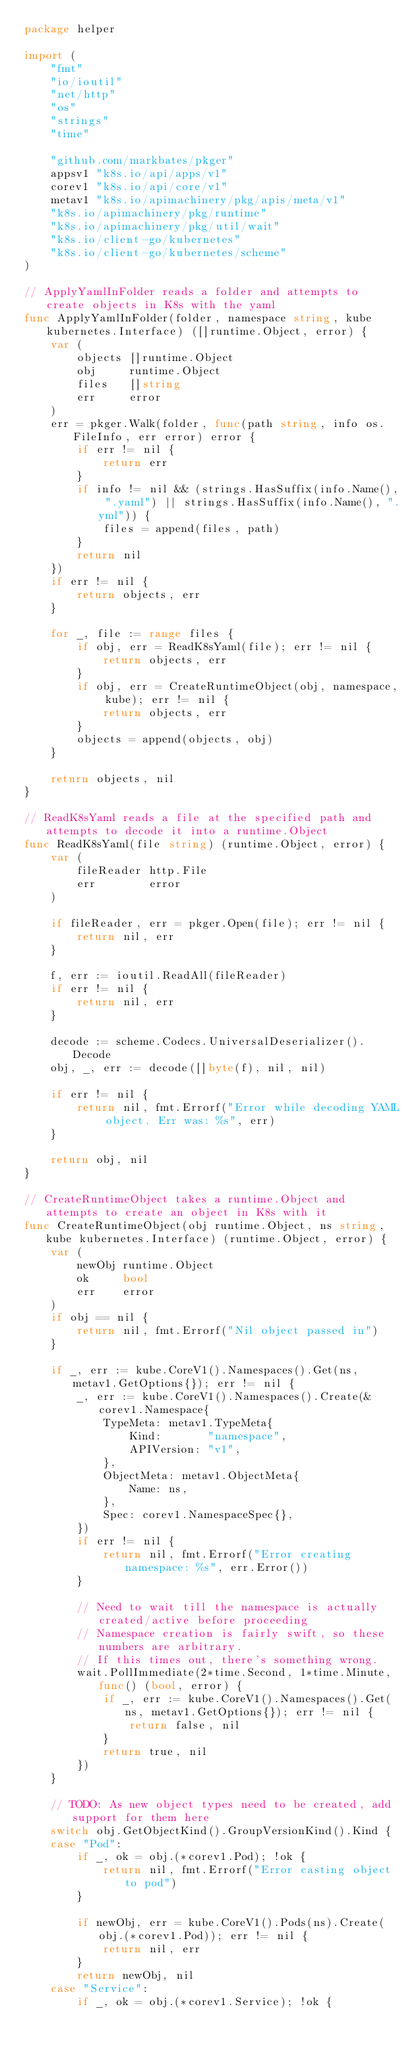<code> <loc_0><loc_0><loc_500><loc_500><_Go_>package helper

import (
	"fmt"
	"io/ioutil"
	"net/http"
	"os"
	"strings"
	"time"

	"github.com/markbates/pkger"
	appsv1 "k8s.io/api/apps/v1"
	corev1 "k8s.io/api/core/v1"
	metav1 "k8s.io/apimachinery/pkg/apis/meta/v1"
	"k8s.io/apimachinery/pkg/runtime"
	"k8s.io/apimachinery/pkg/util/wait"
	"k8s.io/client-go/kubernetes"
	"k8s.io/client-go/kubernetes/scheme"
)

// ApplyYamlInFolder reads a folder and attempts to create objects in K8s with the yaml
func ApplyYamlInFolder(folder, namespace string, kube kubernetes.Interface) ([]runtime.Object, error) {
	var (
		objects []runtime.Object
		obj     runtime.Object
		files   []string
		err     error
	)
	err = pkger.Walk(folder, func(path string, info os.FileInfo, err error) error {
		if err != nil {
			return err
		}
		if info != nil && (strings.HasSuffix(info.Name(), ".yaml") || strings.HasSuffix(info.Name(), ".yml")) {
			files = append(files, path)
		}
		return nil
	})
	if err != nil {
		return objects, err
	}

	for _, file := range files {
		if obj, err = ReadK8sYaml(file); err != nil {
			return objects, err
		}
		if obj, err = CreateRuntimeObject(obj, namespace, kube); err != nil {
			return objects, err
		}
		objects = append(objects, obj)
	}

	return objects, nil
}

// ReadK8sYaml reads a file at the specified path and attempts to decode it into a runtime.Object
func ReadK8sYaml(file string) (runtime.Object, error) {
	var (
		fileReader http.File
		err        error
	)

	if fileReader, err = pkger.Open(file); err != nil {
		return nil, err
	}

	f, err := ioutil.ReadAll(fileReader)
	if err != nil {
		return nil, err
	}

	decode := scheme.Codecs.UniversalDeserializer().Decode
	obj, _, err := decode([]byte(f), nil, nil)

	if err != nil {
		return nil, fmt.Errorf("Error while decoding YAML object. Err was: %s", err)
	}

	return obj, nil
}

// CreateRuntimeObject takes a runtime.Object and attempts to create an object in K8s with it
func CreateRuntimeObject(obj runtime.Object, ns string, kube kubernetes.Interface) (runtime.Object, error) {
	var (
		newObj runtime.Object
		ok     bool
		err    error
	)
	if obj == nil {
		return nil, fmt.Errorf("Nil object passed in")
	}

	if _, err := kube.CoreV1().Namespaces().Get(ns, metav1.GetOptions{}); err != nil {
		_, err := kube.CoreV1().Namespaces().Create(&corev1.Namespace{
			TypeMeta: metav1.TypeMeta{
				Kind:       "namespace",
				APIVersion: "v1",
			},
			ObjectMeta: metav1.ObjectMeta{
				Name: ns,
			},
			Spec: corev1.NamespaceSpec{},
		})
		if err != nil {
			return nil, fmt.Errorf("Error creating namespace: %s", err.Error())
		}

		// Need to wait till the namespace is actually created/active before proceeding
		// Namespace creation is fairly swift, so these numbers are arbitrary.
		// If this times out, there's something wrong.
		wait.PollImmediate(2*time.Second, 1*time.Minute, func() (bool, error) {
			if _, err := kube.CoreV1().Namespaces().Get(ns, metav1.GetOptions{}); err != nil {
				return false, nil
			}
			return true, nil
		})
	}

	// TODO: As new object types need to be created, add support for them here
	switch obj.GetObjectKind().GroupVersionKind().Kind {
	case "Pod":
		if _, ok = obj.(*corev1.Pod); !ok {
			return nil, fmt.Errorf("Error casting object to pod")
		}

		if newObj, err = kube.CoreV1().Pods(ns).Create(obj.(*corev1.Pod)); err != nil {
			return nil, err
		}
		return newObj, nil
	case "Service":
		if _, ok = obj.(*corev1.Service); !ok {</code> 